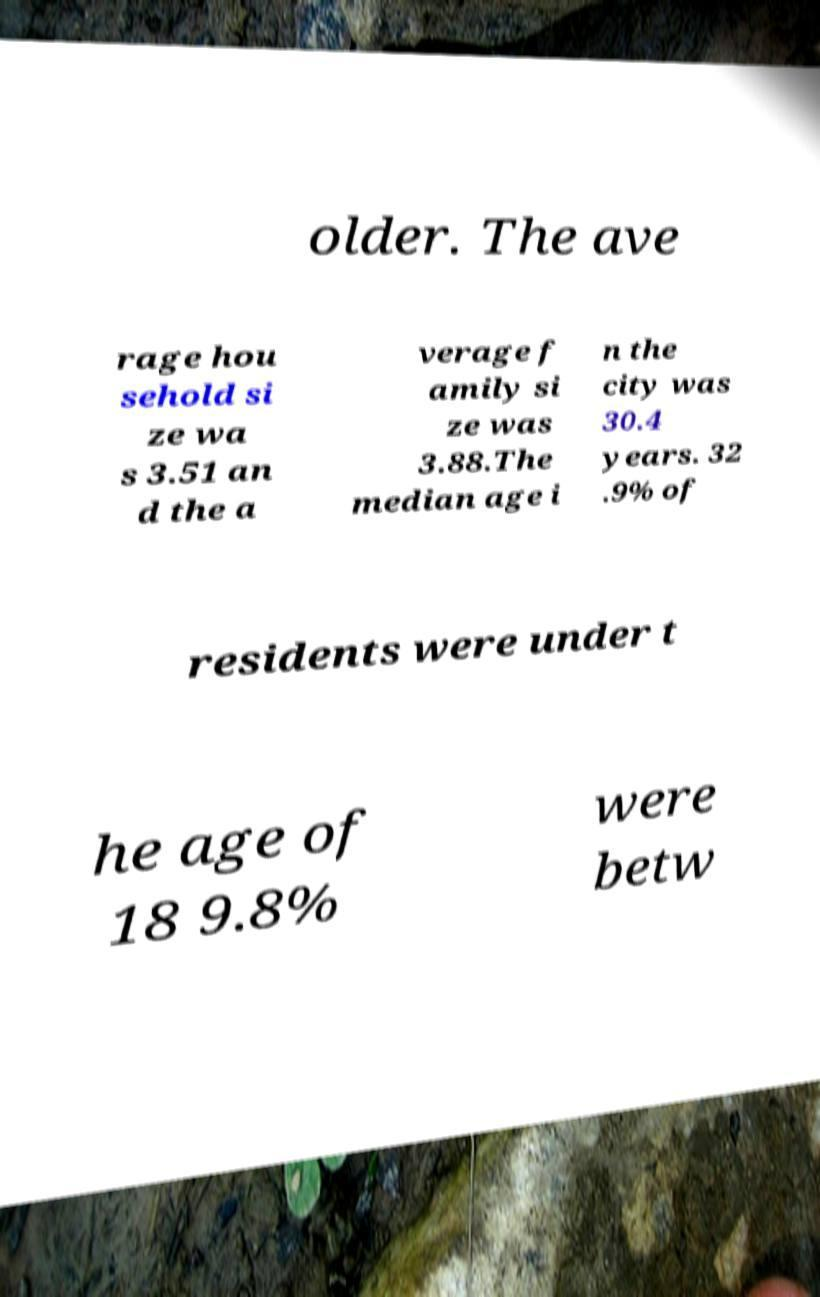Can you read and provide the text displayed in the image?This photo seems to have some interesting text. Can you extract and type it out for me? older. The ave rage hou sehold si ze wa s 3.51 an d the a verage f amily si ze was 3.88.The median age i n the city was 30.4 years. 32 .9% of residents were under t he age of 18 9.8% were betw 